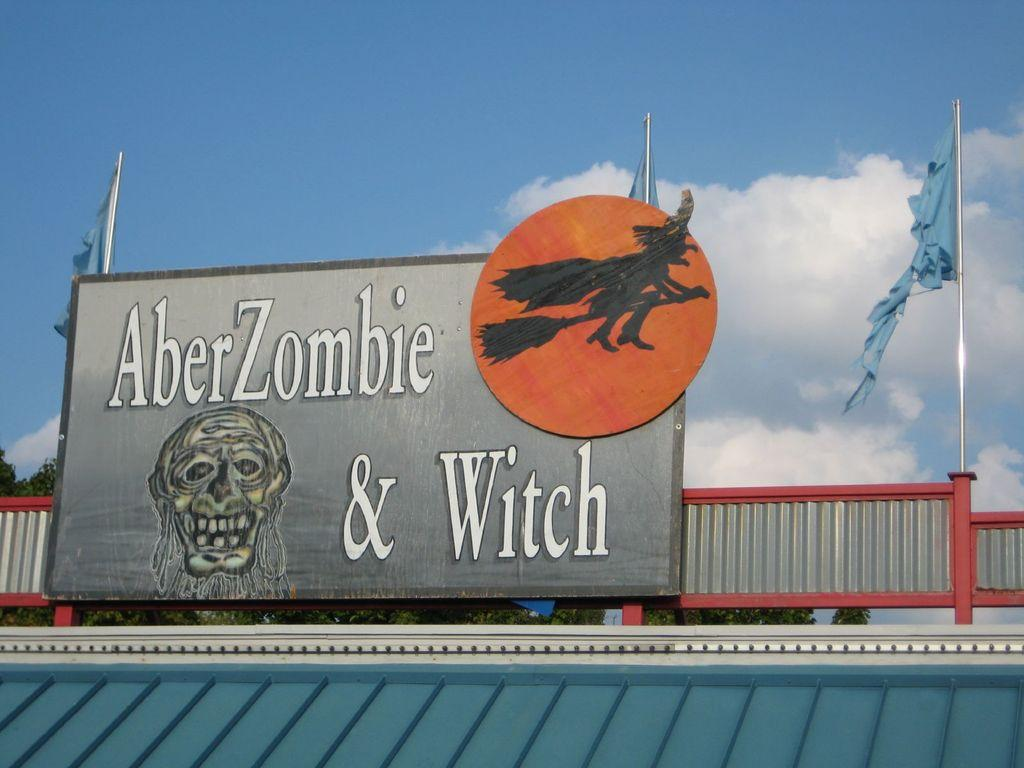<image>
Provide a brief description of the given image. A sign for AberZombie & Witch is on top of a building with light blue flags. 